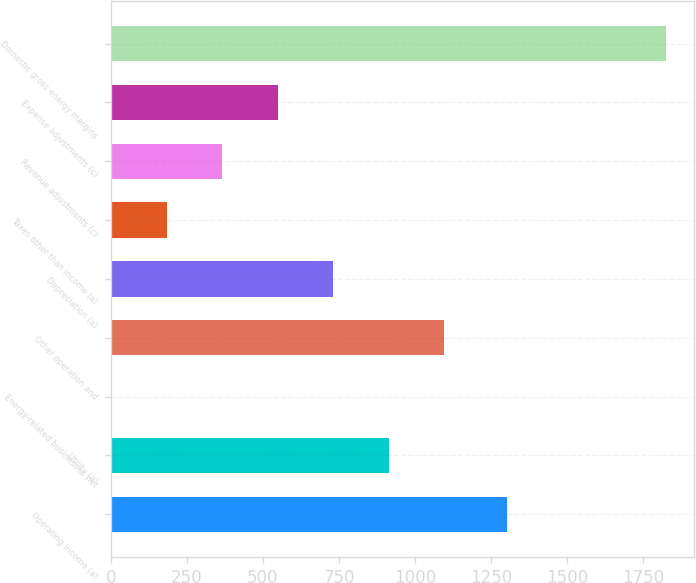Convert chart to OTSL. <chart><loc_0><loc_0><loc_500><loc_500><bar_chart><fcel>Operating Income (a)<fcel>Utility (a)<fcel>Energy-related businesses net<fcel>Other operation and<fcel>Depreciation (a)<fcel>Taxes other than income (a)<fcel>Revenue adjustments (c)<fcel>Expense adjustments (c)<fcel>Domestic gross energy margins<nl><fcel>1302<fcel>913.5<fcel>3<fcel>1095.6<fcel>731.4<fcel>185.1<fcel>367.2<fcel>549.3<fcel>1824<nl></chart> 